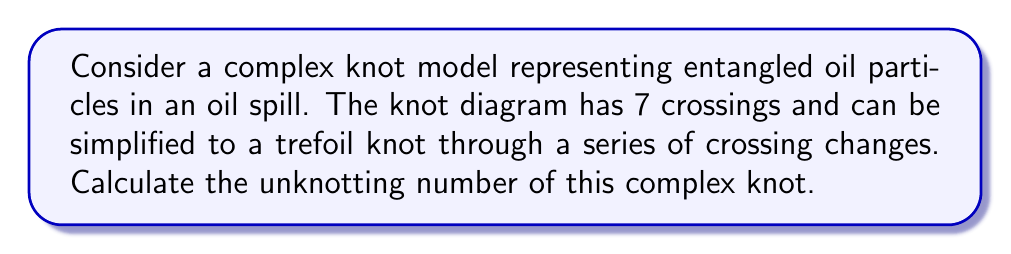Can you answer this question? To solve this problem, we'll follow these steps:

1) First, recall that the unknotting number of a knot is the minimum number of crossing changes required to transform the knot into the unknot (trivial knot).

2) We're given that the complex knot can be simplified to a trefoil knot. This means we need to:
   a) Find the number of crossing changes to simplify the complex knot to a trefoil knot
   b) Add the unknotting number of the trefoil knot

3) To simplify the complex knot to a trefoil:
   - The complex knot has 7 crossings
   - The trefoil knot has 3 crossings
   - Number of crossing changes = 7 - 3 = 4

4) The unknotting number of a trefoil knot is known to be 1.

5) Therefore, the total unknotting number is:
   $$U = 4 + 1 = 5$$

This means that a minimum of 5 crossing changes are required to transform the complex knot representing entangled oil particles into the unknot.

[asy]
import geometry;

pair[] points = {(0,0), (1,1), (2,0), (1,-1)};
path trefoil = points[0]..points[1]..points[2]..points[3]..cycle;

draw(trefoil, black+1);
draw(shift(1.5,0.5)*rotate(210)*trefoil, gray+dashed);

label("Complex knot", (3.5,1), E);
label("Trefoil", (1.5,-1.5), S);
label("4 changes", (2.5,0), NE);
label("1 change", (0.5,-0.5), NW);

draw((2.5,0.5)--(3.3,0.8), arrow=Arrow);
draw((0.7,-0.7)--(0.3,-1), arrow=Arrow);
[/asy]
Answer: 5 